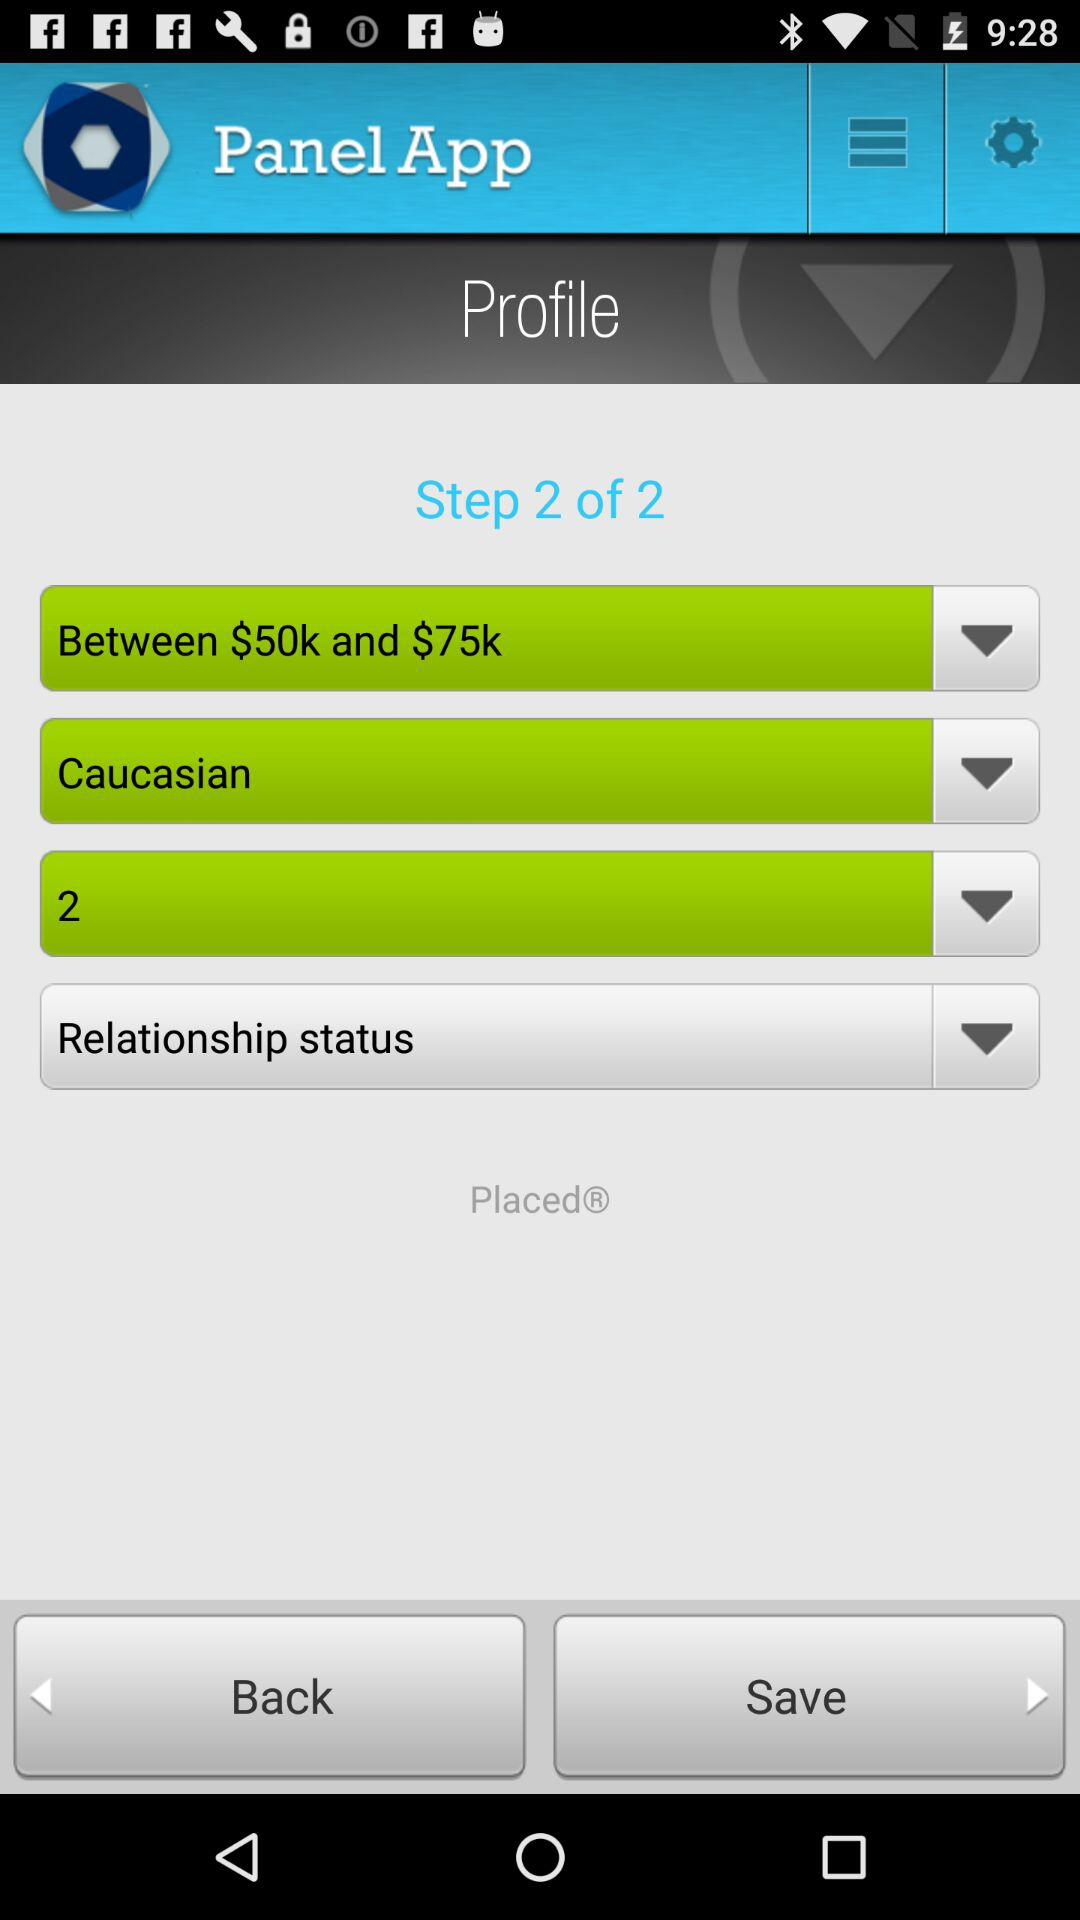What step am I currently at? You are on step 2. 